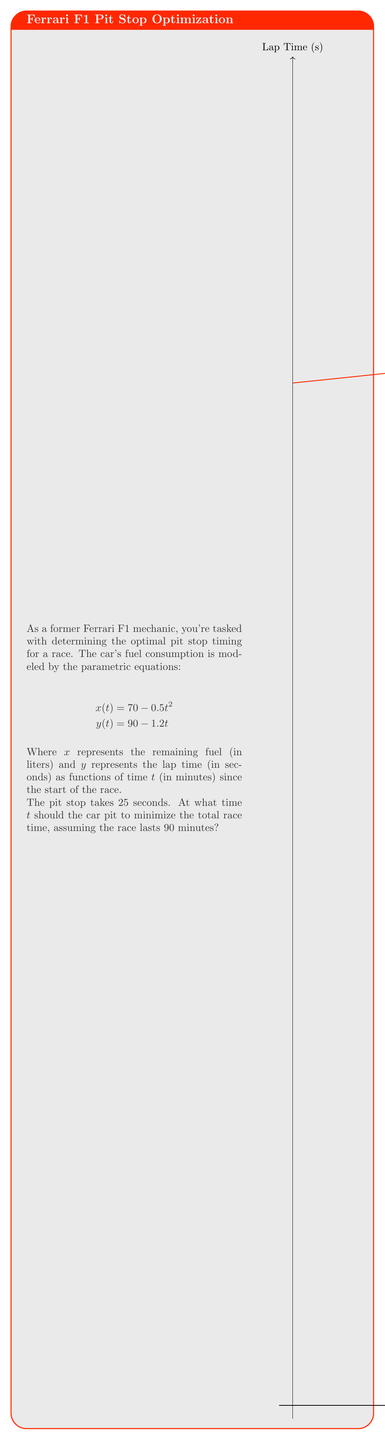Can you solve this math problem? To solve this problem, we'll follow these steps:

1) First, we need to find the total distance covered in 90 minutes without a pit stop. This is given by the integral of the reciprocal of y(t) from 0 to 90:

   $$D = \int_0^{90} \frac{1}{90 - 1.2t} dt$$

2) Evaluating this integral:
   
   $$D = -\frac{1}{1.2} \ln(90 - 1.2t) \bigg|_0^{90} = 62.13 \text{ laps}$$

3) Now, let's say we pit at time $t$. The total race distance will be:

   $$D_t = \int_0^t \frac{1}{90 - 1.2t} dt + \int_t^{90} \frac{1}{90 - 1.2t} dt$$

   The first integral represents the distance before the pit stop, and the second integral represents the distance after the pit stop.

4) We need to account for the 25-second pit stop. This is equivalent to losing $\frac{25}{90-1.2t}$ laps at the time of the pit stop.

5) So, our goal is to maximize:

   $$F(t) = -\frac{1}{1.2} \ln(90 - 1.2t) \bigg|_0^t - \frac{1}{1.2} \ln(90 - 1.2t) \bigg|_t^{90} - \frac{25}{90-1.2t}$$

6) Simplifying:

   $$F(t) = 62.13 - \frac{25}{90-1.2t}$$

7) To find the maximum, we differentiate and set to zero:

   $$F'(t) = \frac{30}{(90-1.2t)^2} = 0$$

8) This is always positive for valid $t$, meaning $F(t)$ is always increasing. Therefore, we should pit as late as possible while ensuring we have enough fuel.

9) From the fuel equation, we can find when we run out of fuel:

   $$70 - 0.5t^2 = 0$$
   $$t = \sqrt{140} \approx 11.83 \text{ minutes}$$

10) Therefore, we should pit just before this time, let's say at $t = 11.5$ minutes.
Answer: 11.5 minutes 